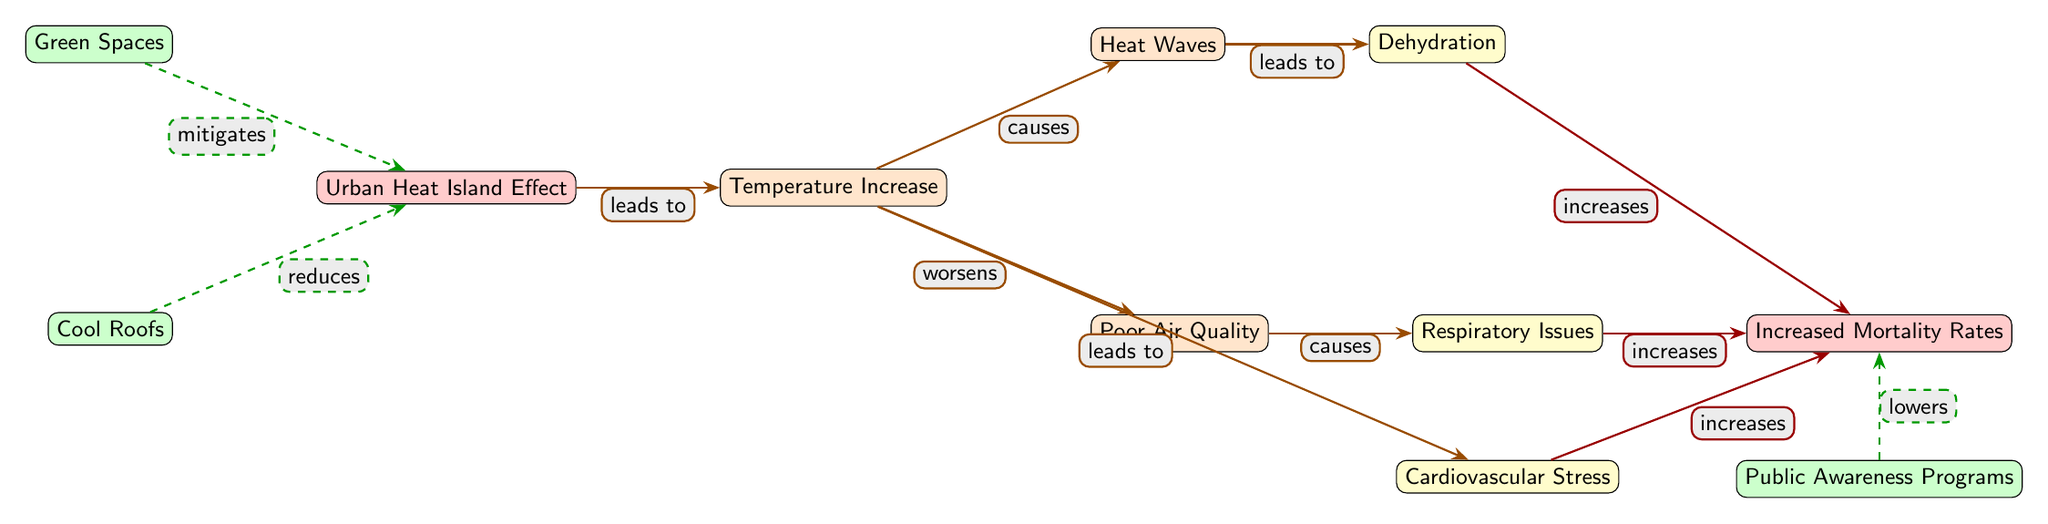What is the main effect of the Urban Heat Island Effect? The Urban Heat Island Effect leads to an increase in temperature, as indicated by the directed edge from the Urban Heat Island Effect node to the Temperature Increase node.
Answer: Temperature Increase How many mitigation strategies are depicted in the diagram? The diagram shows three mitigation strategies: Green Spaces, Cool Roofs, and Public Awareness Programs. They can be counted as distinct nodes leading to different connections.
Answer: 3 Which node is directly affected by Poor Air Quality? Poor Air Quality directly influences the Respiratory Issues node, as evidenced by the edge connecting the Poor Air Quality node to the Respiratory Issues node.
Answer: Respiratory Issues What type of effects does Dehydration have on mortality rates? The diagram illustrates that Dehydration increases mortality rates, as the edge labeled "increases" connects Dehydration to Increased Mortality Rates.
Answer: Increases Which mitigation strategy is related to reducing the Urban Heat Island Effect? Cool Roofs are identified in the diagram as a strategy that reduces the Urban Heat Island Effect, connected by a dashed line from the Cool Roofs node to the Urban Heat Island Effect node.
Answer: Reduces What problem arises due to Heat Waves? Heat Waves lead to Dehydration, as shown by the arrow stating "leads to" that connects the Heat Waves node to the Dehydration node.
Answer: Dehydration What is the relationship between Temperature Increase and Cardiovascular Stress? The Temperature Increase worsens Cardiovascular Stress, which is indicated by the directed edge labeled "leads to" from Temperature Increase to Cardiovascular Stress.
Answer: Worsens How does Public Awareness Programs influence Increased Mortality Rates? Public Awareness Programs lower mortality rates, connecting to the Increased Mortality Rates node through a dashed line marked "lowers."
Answer: Lowers Which factor contributes directly to Increased Mortality Rates? All three factors—Dehydration, Respiratory Issues, and Cardiovascular Stress contribute directly to Increased Mortality Rates, as evidenced by their connections labeled "increases."
Answer: All three factors 